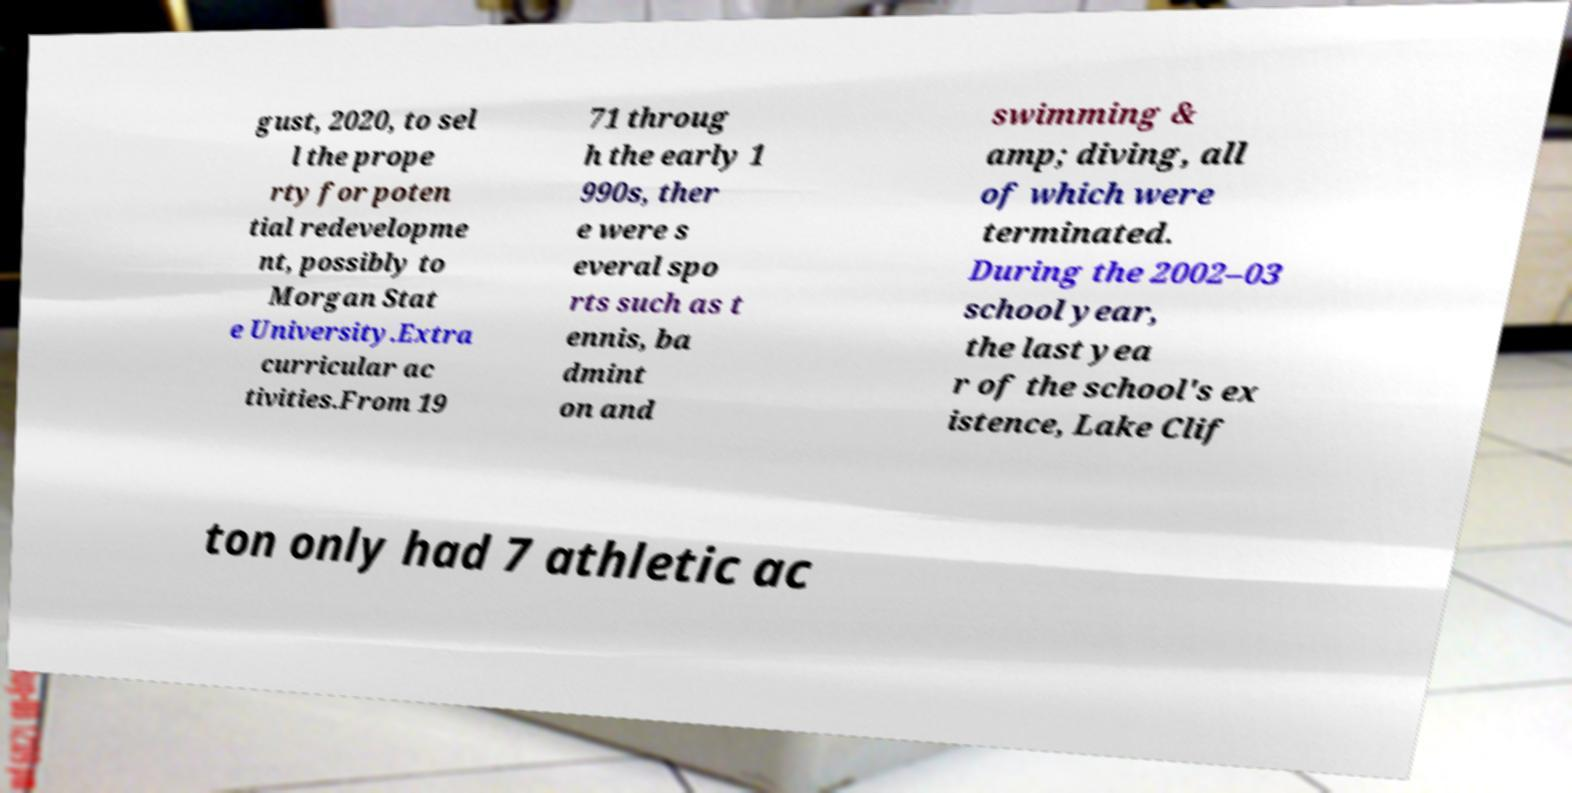Could you assist in decoding the text presented in this image and type it out clearly? gust, 2020, to sel l the prope rty for poten tial redevelopme nt, possibly to Morgan Stat e University.Extra curricular ac tivities.From 19 71 throug h the early 1 990s, ther e were s everal spo rts such as t ennis, ba dmint on and swimming & amp; diving, all of which were terminated. During the 2002–03 school year, the last yea r of the school's ex istence, Lake Clif ton only had 7 athletic ac 